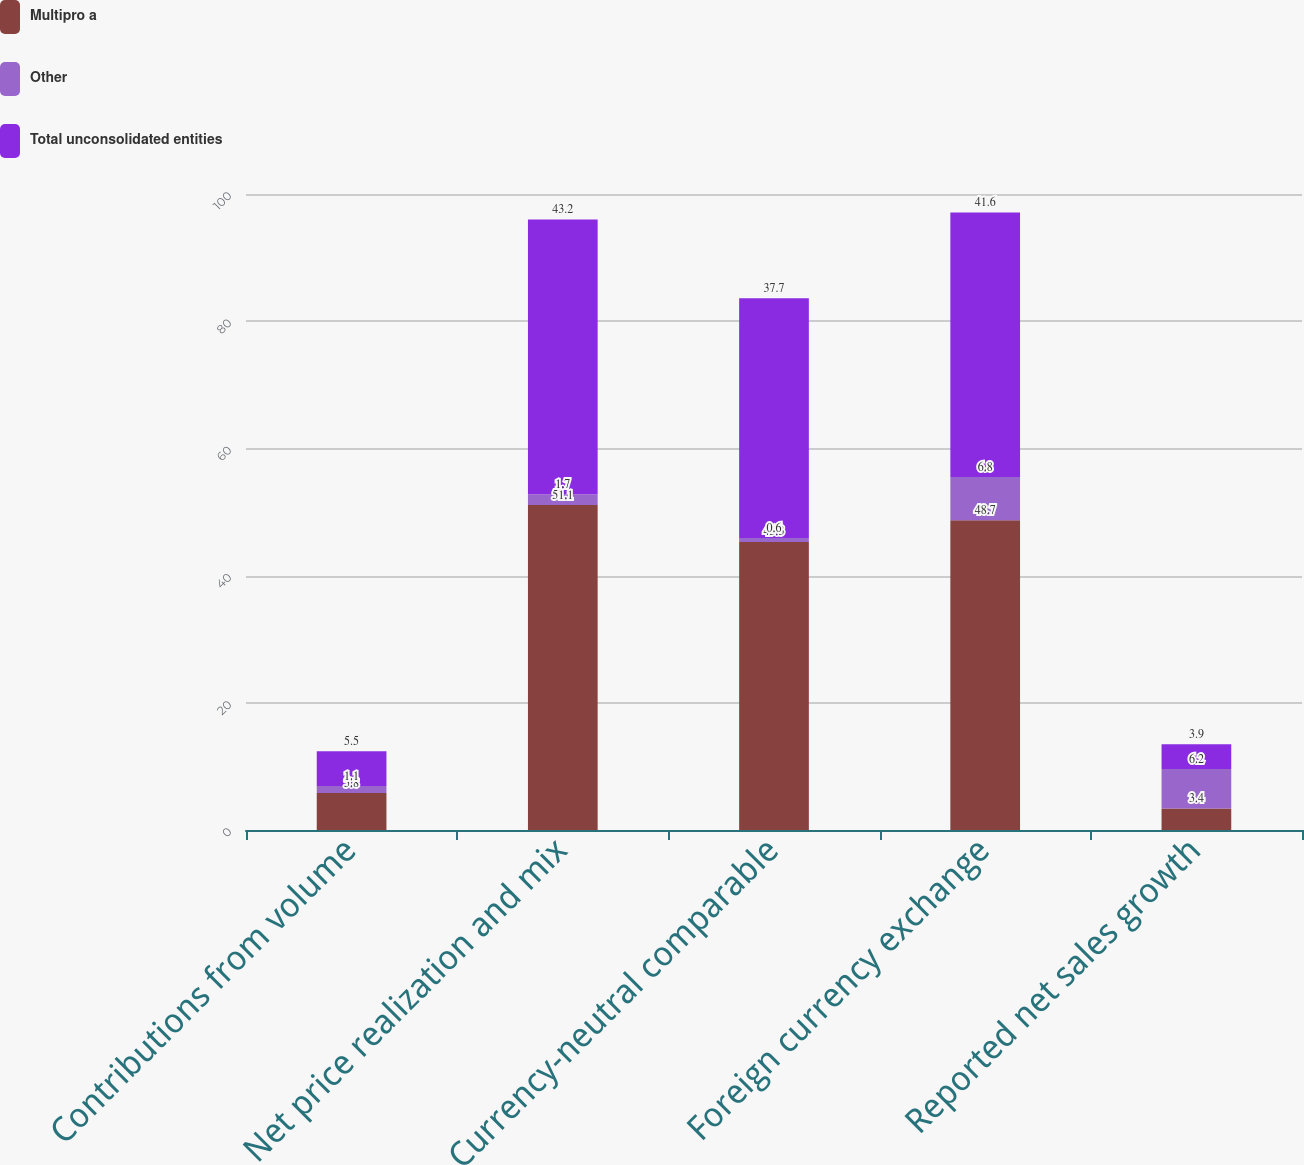<chart> <loc_0><loc_0><loc_500><loc_500><stacked_bar_chart><ecel><fcel>Contributions from volume<fcel>Net price realization and mix<fcel>Currency-neutral comparable<fcel>Foreign currency exchange<fcel>Reported net sales growth<nl><fcel>Multipro a<fcel>5.8<fcel>51.1<fcel>45.3<fcel>48.7<fcel>3.4<nl><fcel>Other<fcel>1.1<fcel>1.7<fcel>0.6<fcel>6.8<fcel>6.2<nl><fcel>Total unconsolidated entities<fcel>5.5<fcel>43.2<fcel>37.7<fcel>41.6<fcel>3.9<nl></chart> 